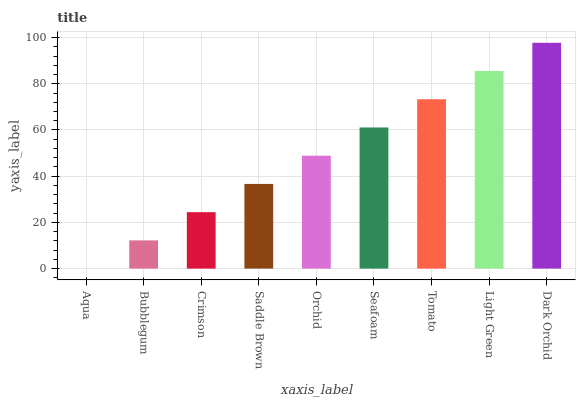Is Aqua the minimum?
Answer yes or no. Yes. Is Dark Orchid the maximum?
Answer yes or no. Yes. Is Bubblegum the minimum?
Answer yes or no. No. Is Bubblegum the maximum?
Answer yes or no. No. Is Bubblegum greater than Aqua?
Answer yes or no. Yes. Is Aqua less than Bubblegum?
Answer yes or no. Yes. Is Aqua greater than Bubblegum?
Answer yes or no. No. Is Bubblegum less than Aqua?
Answer yes or no. No. Is Orchid the high median?
Answer yes or no. Yes. Is Orchid the low median?
Answer yes or no. Yes. Is Bubblegum the high median?
Answer yes or no. No. Is Dark Orchid the low median?
Answer yes or no. No. 